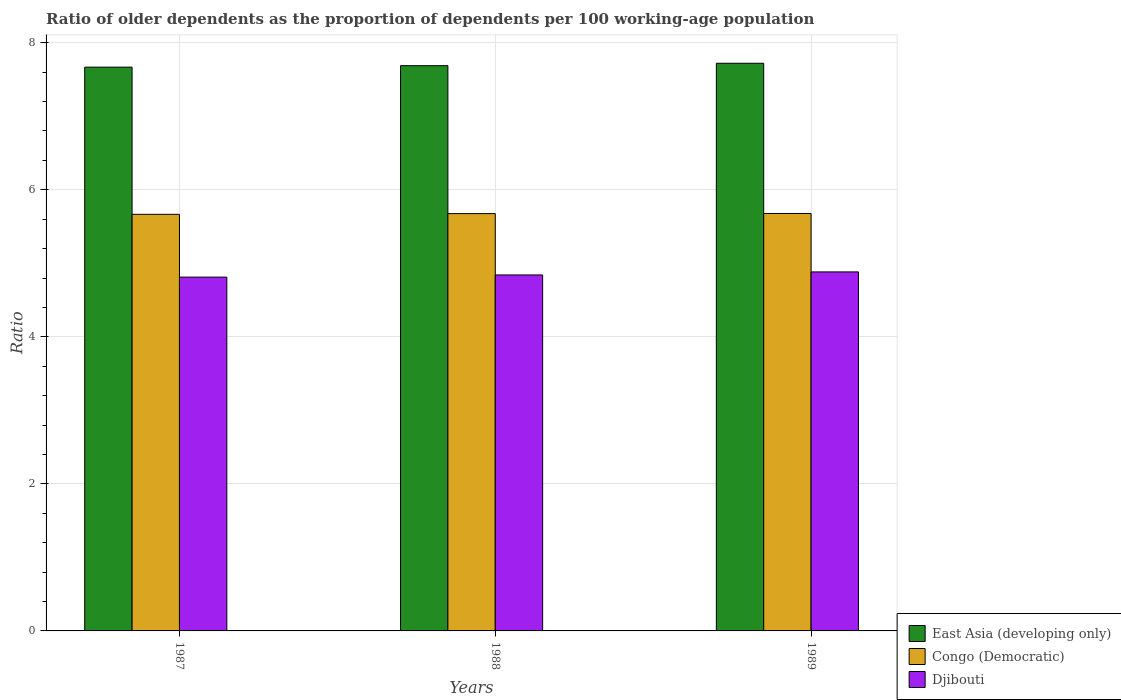How many groups of bars are there?
Your response must be concise. 3. What is the label of the 2nd group of bars from the left?
Offer a terse response. 1988. In how many cases, is the number of bars for a given year not equal to the number of legend labels?
Offer a terse response. 0. What is the age dependency ratio(old) in Congo (Democratic) in 1989?
Your response must be concise. 5.68. Across all years, what is the maximum age dependency ratio(old) in East Asia (developing only)?
Offer a terse response. 7.72. Across all years, what is the minimum age dependency ratio(old) in Djibouti?
Provide a succinct answer. 4.81. In which year was the age dependency ratio(old) in Congo (Democratic) maximum?
Your answer should be compact. 1989. What is the total age dependency ratio(old) in Congo (Democratic) in the graph?
Make the answer very short. 17.02. What is the difference between the age dependency ratio(old) in Djibouti in 1988 and that in 1989?
Offer a terse response. -0.04. What is the difference between the age dependency ratio(old) in Congo (Democratic) in 1988 and the age dependency ratio(old) in East Asia (developing only) in 1989?
Your answer should be compact. -2.04. What is the average age dependency ratio(old) in Congo (Democratic) per year?
Make the answer very short. 5.67. In the year 1987, what is the difference between the age dependency ratio(old) in East Asia (developing only) and age dependency ratio(old) in Djibouti?
Offer a terse response. 2.86. What is the ratio of the age dependency ratio(old) in Djibouti in 1987 to that in 1988?
Give a very brief answer. 0.99. What is the difference between the highest and the second highest age dependency ratio(old) in East Asia (developing only)?
Make the answer very short. 0.03. What is the difference between the highest and the lowest age dependency ratio(old) in East Asia (developing only)?
Your answer should be very brief. 0.05. What does the 2nd bar from the left in 1987 represents?
Provide a short and direct response. Congo (Democratic). What does the 1st bar from the right in 1988 represents?
Give a very brief answer. Djibouti. How many years are there in the graph?
Offer a very short reply. 3. Are the values on the major ticks of Y-axis written in scientific E-notation?
Offer a very short reply. No. How many legend labels are there?
Your answer should be very brief. 3. How are the legend labels stacked?
Offer a terse response. Vertical. What is the title of the graph?
Your answer should be compact. Ratio of older dependents as the proportion of dependents per 100 working-age population. What is the label or title of the Y-axis?
Ensure brevity in your answer.  Ratio. What is the Ratio in East Asia (developing only) in 1987?
Ensure brevity in your answer.  7.67. What is the Ratio in Congo (Democratic) in 1987?
Keep it short and to the point. 5.67. What is the Ratio in Djibouti in 1987?
Your answer should be very brief. 4.81. What is the Ratio of East Asia (developing only) in 1988?
Give a very brief answer. 7.69. What is the Ratio of Congo (Democratic) in 1988?
Provide a short and direct response. 5.68. What is the Ratio in Djibouti in 1988?
Your answer should be compact. 4.84. What is the Ratio of East Asia (developing only) in 1989?
Make the answer very short. 7.72. What is the Ratio of Congo (Democratic) in 1989?
Make the answer very short. 5.68. What is the Ratio in Djibouti in 1989?
Your response must be concise. 4.88. Across all years, what is the maximum Ratio of East Asia (developing only)?
Offer a very short reply. 7.72. Across all years, what is the maximum Ratio in Congo (Democratic)?
Your response must be concise. 5.68. Across all years, what is the maximum Ratio of Djibouti?
Your answer should be compact. 4.88. Across all years, what is the minimum Ratio of East Asia (developing only)?
Make the answer very short. 7.67. Across all years, what is the minimum Ratio of Congo (Democratic)?
Your answer should be very brief. 5.67. Across all years, what is the minimum Ratio of Djibouti?
Your response must be concise. 4.81. What is the total Ratio of East Asia (developing only) in the graph?
Your answer should be very brief. 23.08. What is the total Ratio in Congo (Democratic) in the graph?
Your answer should be compact. 17.02. What is the total Ratio in Djibouti in the graph?
Give a very brief answer. 14.54. What is the difference between the Ratio of East Asia (developing only) in 1987 and that in 1988?
Offer a very short reply. -0.02. What is the difference between the Ratio of Congo (Democratic) in 1987 and that in 1988?
Provide a short and direct response. -0.01. What is the difference between the Ratio of Djibouti in 1987 and that in 1988?
Keep it short and to the point. -0.03. What is the difference between the Ratio in East Asia (developing only) in 1987 and that in 1989?
Your answer should be compact. -0.05. What is the difference between the Ratio of Congo (Democratic) in 1987 and that in 1989?
Keep it short and to the point. -0.01. What is the difference between the Ratio in Djibouti in 1987 and that in 1989?
Give a very brief answer. -0.07. What is the difference between the Ratio in East Asia (developing only) in 1988 and that in 1989?
Keep it short and to the point. -0.03. What is the difference between the Ratio in Congo (Democratic) in 1988 and that in 1989?
Offer a very short reply. -0. What is the difference between the Ratio of Djibouti in 1988 and that in 1989?
Ensure brevity in your answer.  -0.04. What is the difference between the Ratio in East Asia (developing only) in 1987 and the Ratio in Congo (Democratic) in 1988?
Provide a succinct answer. 1.99. What is the difference between the Ratio in East Asia (developing only) in 1987 and the Ratio in Djibouti in 1988?
Offer a very short reply. 2.83. What is the difference between the Ratio in Congo (Democratic) in 1987 and the Ratio in Djibouti in 1988?
Offer a very short reply. 0.82. What is the difference between the Ratio of East Asia (developing only) in 1987 and the Ratio of Congo (Democratic) in 1989?
Your answer should be very brief. 1.99. What is the difference between the Ratio of East Asia (developing only) in 1987 and the Ratio of Djibouti in 1989?
Offer a terse response. 2.79. What is the difference between the Ratio of Congo (Democratic) in 1987 and the Ratio of Djibouti in 1989?
Provide a succinct answer. 0.78. What is the difference between the Ratio in East Asia (developing only) in 1988 and the Ratio in Congo (Democratic) in 1989?
Provide a short and direct response. 2.01. What is the difference between the Ratio of East Asia (developing only) in 1988 and the Ratio of Djibouti in 1989?
Your answer should be very brief. 2.81. What is the difference between the Ratio in Congo (Democratic) in 1988 and the Ratio in Djibouti in 1989?
Ensure brevity in your answer.  0.79. What is the average Ratio in East Asia (developing only) per year?
Keep it short and to the point. 7.69. What is the average Ratio of Congo (Democratic) per year?
Give a very brief answer. 5.67. What is the average Ratio of Djibouti per year?
Provide a succinct answer. 4.85. In the year 1987, what is the difference between the Ratio of East Asia (developing only) and Ratio of Congo (Democratic)?
Give a very brief answer. 2. In the year 1987, what is the difference between the Ratio in East Asia (developing only) and Ratio in Djibouti?
Your answer should be very brief. 2.86. In the year 1987, what is the difference between the Ratio in Congo (Democratic) and Ratio in Djibouti?
Provide a short and direct response. 0.85. In the year 1988, what is the difference between the Ratio in East Asia (developing only) and Ratio in Congo (Democratic)?
Give a very brief answer. 2.01. In the year 1988, what is the difference between the Ratio in East Asia (developing only) and Ratio in Djibouti?
Your answer should be very brief. 2.85. In the year 1988, what is the difference between the Ratio in Congo (Democratic) and Ratio in Djibouti?
Provide a succinct answer. 0.83. In the year 1989, what is the difference between the Ratio of East Asia (developing only) and Ratio of Congo (Democratic)?
Your response must be concise. 2.04. In the year 1989, what is the difference between the Ratio in East Asia (developing only) and Ratio in Djibouti?
Offer a terse response. 2.84. In the year 1989, what is the difference between the Ratio in Congo (Democratic) and Ratio in Djibouti?
Ensure brevity in your answer.  0.8. What is the ratio of the Ratio of Djibouti in 1987 to that in 1988?
Make the answer very short. 0.99. What is the ratio of the Ratio in Djibouti in 1987 to that in 1989?
Keep it short and to the point. 0.99. What is the difference between the highest and the second highest Ratio of East Asia (developing only)?
Ensure brevity in your answer.  0.03. What is the difference between the highest and the second highest Ratio in Congo (Democratic)?
Provide a succinct answer. 0. What is the difference between the highest and the second highest Ratio of Djibouti?
Provide a short and direct response. 0.04. What is the difference between the highest and the lowest Ratio in East Asia (developing only)?
Offer a terse response. 0.05. What is the difference between the highest and the lowest Ratio in Congo (Democratic)?
Your answer should be compact. 0.01. What is the difference between the highest and the lowest Ratio of Djibouti?
Your answer should be very brief. 0.07. 